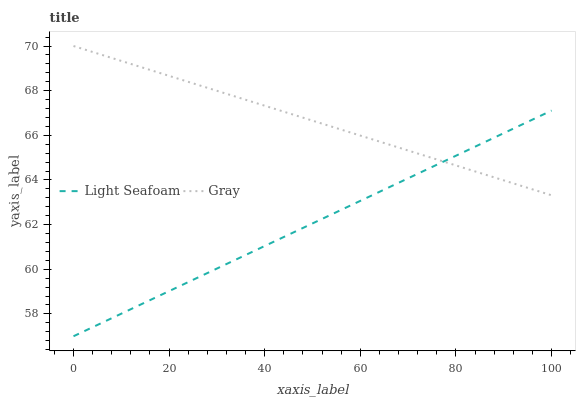Does Light Seafoam have the minimum area under the curve?
Answer yes or no. Yes. Does Gray have the maximum area under the curve?
Answer yes or no. Yes. Does Light Seafoam have the maximum area under the curve?
Answer yes or no. No. Is Light Seafoam the smoothest?
Answer yes or no. Yes. Is Gray the roughest?
Answer yes or no. Yes. Is Light Seafoam the roughest?
Answer yes or no. No. Does Light Seafoam have the lowest value?
Answer yes or no. Yes. Does Gray have the highest value?
Answer yes or no. Yes. Does Light Seafoam have the highest value?
Answer yes or no. No. Does Light Seafoam intersect Gray?
Answer yes or no. Yes. Is Light Seafoam less than Gray?
Answer yes or no. No. Is Light Seafoam greater than Gray?
Answer yes or no. No. 